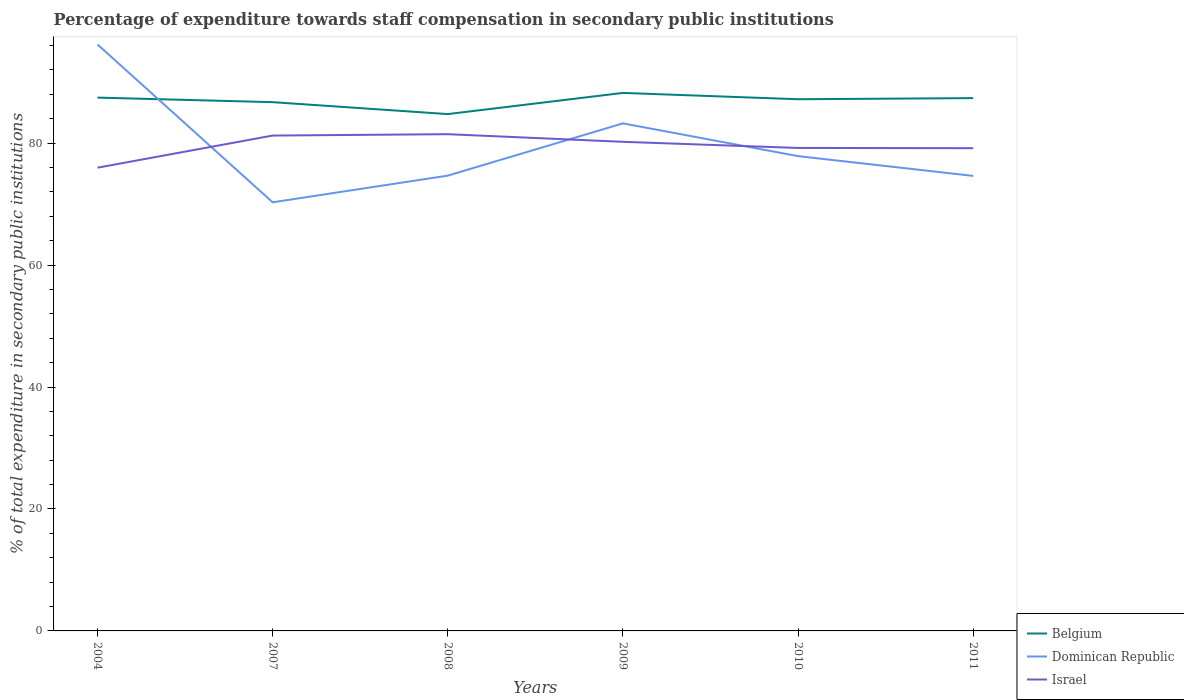How many different coloured lines are there?
Give a very brief answer. 3. Does the line corresponding to Belgium intersect with the line corresponding to Israel?
Give a very brief answer. No. Is the number of lines equal to the number of legend labels?
Provide a short and direct response. Yes. Across all years, what is the maximum percentage of expenditure towards staff compensation in Dominican Republic?
Your answer should be very brief. 70.3. In which year was the percentage of expenditure towards staff compensation in Dominican Republic maximum?
Provide a succinct answer. 2007. What is the total percentage of expenditure towards staff compensation in Dominican Republic in the graph?
Your answer should be very brief. 12.94. What is the difference between the highest and the second highest percentage of expenditure towards staff compensation in Belgium?
Make the answer very short. 3.47. How many lines are there?
Give a very brief answer. 3. What is the difference between two consecutive major ticks on the Y-axis?
Your answer should be compact. 20. Does the graph contain grids?
Give a very brief answer. No. How are the legend labels stacked?
Give a very brief answer. Vertical. What is the title of the graph?
Keep it short and to the point. Percentage of expenditure towards staff compensation in secondary public institutions. Does "New Zealand" appear as one of the legend labels in the graph?
Provide a short and direct response. No. What is the label or title of the X-axis?
Your answer should be very brief. Years. What is the label or title of the Y-axis?
Provide a succinct answer. % of total expenditure in secondary public institutions. What is the % of total expenditure in secondary public institutions in Belgium in 2004?
Your answer should be compact. 87.47. What is the % of total expenditure in secondary public institutions of Dominican Republic in 2004?
Your answer should be very brief. 96.18. What is the % of total expenditure in secondary public institutions in Israel in 2004?
Provide a short and direct response. 75.97. What is the % of total expenditure in secondary public institutions in Belgium in 2007?
Make the answer very short. 86.72. What is the % of total expenditure in secondary public institutions of Dominican Republic in 2007?
Keep it short and to the point. 70.3. What is the % of total expenditure in secondary public institutions of Israel in 2007?
Provide a succinct answer. 81.24. What is the % of total expenditure in secondary public institutions in Belgium in 2008?
Ensure brevity in your answer.  84.77. What is the % of total expenditure in secondary public institutions of Dominican Republic in 2008?
Make the answer very short. 74.67. What is the % of total expenditure in secondary public institutions in Israel in 2008?
Your answer should be compact. 81.47. What is the % of total expenditure in secondary public institutions of Belgium in 2009?
Provide a short and direct response. 88.24. What is the % of total expenditure in secondary public institutions in Dominican Republic in 2009?
Give a very brief answer. 83.24. What is the % of total expenditure in secondary public institutions in Israel in 2009?
Provide a succinct answer. 80.22. What is the % of total expenditure in secondary public institutions in Belgium in 2010?
Keep it short and to the point. 87.2. What is the % of total expenditure in secondary public institutions in Dominican Republic in 2010?
Provide a succinct answer. 77.87. What is the % of total expenditure in secondary public institutions of Israel in 2010?
Offer a very short reply. 79.21. What is the % of total expenditure in secondary public institutions in Belgium in 2011?
Offer a terse response. 87.38. What is the % of total expenditure in secondary public institutions in Dominican Republic in 2011?
Make the answer very short. 74.63. What is the % of total expenditure in secondary public institutions in Israel in 2011?
Your answer should be very brief. 79.17. Across all years, what is the maximum % of total expenditure in secondary public institutions in Belgium?
Offer a very short reply. 88.24. Across all years, what is the maximum % of total expenditure in secondary public institutions of Dominican Republic?
Keep it short and to the point. 96.18. Across all years, what is the maximum % of total expenditure in secondary public institutions of Israel?
Provide a succinct answer. 81.47. Across all years, what is the minimum % of total expenditure in secondary public institutions in Belgium?
Offer a very short reply. 84.77. Across all years, what is the minimum % of total expenditure in secondary public institutions of Dominican Republic?
Provide a succinct answer. 70.3. Across all years, what is the minimum % of total expenditure in secondary public institutions of Israel?
Your answer should be compact. 75.97. What is the total % of total expenditure in secondary public institutions of Belgium in the graph?
Provide a short and direct response. 521.78. What is the total % of total expenditure in secondary public institutions of Dominican Republic in the graph?
Keep it short and to the point. 476.89. What is the total % of total expenditure in secondary public institutions of Israel in the graph?
Keep it short and to the point. 477.29. What is the difference between the % of total expenditure in secondary public institutions in Belgium in 2004 and that in 2007?
Offer a terse response. 0.75. What is the difference between the % of total expenditure in secondary public institutions in Dominican Republic in 2004 and that in 2007?
Your answer should be very brief. 25.89. What is the difference between the % of total expenditure in secondary public institutions of Israel in 2004 and that in 2007?
Your answer should be compact. -5.27. What is the difference between the % of total expenditure in secondary public institutions of Belgium in 2004 and that in 2008?
Your answer should be very brief. 2.7. What is the difference between the % of total expenditure in secondary public institutions of Dominican Republic in 2004 and that in 2008?
Your answer should be compact. 21.51. What is the difference between the % of total expenditure in secondary public institutions in Israel in 2004 and that in 2008?
Keep it short and to the point. -5.49. What is the difference between the % of total expenditure in secondary public institutions of Belgium in 2004 and that in 2009?
Make the answer very short. -0.77. What is the difference between the % of total expenditure in secondary public institutions in Dominican Republic in 2004 and that in 2009?
Make the answer very short. 12.94. What is the difference between the % of total expenditure in secondary public institutions in Israel in 2004 and that in 2009?
Make the answer very short. -4.24. What is the difference between the % of total expenditure in secondary public institutions of Belgium in 2004 and that in 2010?
Provide a succinct answer. 0.27. What is the difference between the % of total expenditure in secondary public institutions of Dominican Republic in 2004 and that in 2010?
Provide a succinct answer. 18.31. What is the difference between the % of total expenditure in secondary public institutions in Israel in 2004 and that in 2010?
Your answer should be compact. -3.24. What is the difference between the % of total expenditure in secondary public institutions of Belgium in 2004 and that in 2011?
Ensure brevity in your answer.  0.08. What is the difference between the % of total expenditure in secondary public institutions in Dominican Republic in 2004 and that in 2011?
Offer a terse response. 21.56. What is the difference between the % of total expenditure in secondary public institutions in Israel in 2004 and that in 2011?
Make the answer very short. -3.2. What is the difference between the % of total expenditure in secondary public institutions in Belgium in 2007 and that in 2008?
Your answer should be compact. 1.96. What is the difference between the % of total expenditure in secondary public institutions in Dominican Republic in 2007 and that in 2008?
Give a very brief answer. -4.38. What is the difference between the % of total expenditure in secondary public institutions of Israel in 2007 and that in 2008?
Make the answer very short. -0.23. What is the difference between the % of total expenditure in secondary public institutions of Belgium in 2007 and that in 2009?
Ensure brevity in your answer.  -1.52. What is the difference between the % of total expenditure in secondary public institutions in Dominican Republic in 2007 and that in 2009?
Ensure brevity in your answer.  -12.95. What is the difference between the % of total expenditure in secondary public institutions in Israel in 2007 and that in 2009?
Your response must be concise. 1.03. What is the difference between the % of total expenditure in secondary public institutions in Belgium in 2007 and that in 2010?
Ensure brevity in your answer.  -0.48. What is the difference between the % of total expenditure in secondary public institutions in Dominican Republic in 2007 and that in 2010?
Make the answer very short. -7.58. What is the difference between the % of total expenditure in secondary public institutions in Israel in 2007 and that in 2010?
Your answer should be compact. 2.03. What is the difference between the % of total expenditure in secondary public institutions of Belgium in 2007 and that in 2011?
Your answer should be very brief. -0.66. What is the difference between the % of total expenditure in secondary public institutions in Dominican Republic in 2007 and that in 2011?
Your response must be concise. -4.33. What is the difference between the % of total expenditure in secondary public institutions in Israel in 2007 and that in 2011?
Your answer should be compact. 2.07. What is the difference between the % of total expenditure in secondary public institutions of Belgium in 2008 and that in 2009?
Ensure brevity in your answer.  -3.47. What is the difference between the % of total expenditure in secondary public institutions of Dominican Republic in 2008 and that in 2009?
Provide a succinct answer. -8.57. What is the difference between the % of total expenditure in secondary public institutions in Israel in 2008 and that in 2009?
Give a very brief answer. 1.25. What is the difference between the % of total expenditure in secondary public institutions in Belgium in 2008 and that in 2010?
Make the answer very short. -2.43. What is the difference between the % of total expenditure in secondary public institutions in Dominican Republic in 2008 and that in 2010?
Provide a short and direct response. -3.2. What is the difference between the % of total expenditure in secondary public institutions of Israel in 2008 and that in 2010?
Give a very brief answer. 2.26. What is the difference between the % of total expenditure in secondary public institutions in Belgium in 2008 and that in 2011?
Your response must be concise. -2.62. What is the difference between the % of total expenditure in secondary public institutions of Dominican Republic in 2008 and that in 2011?
Your answer should be very brief. 0.05. What is the difference between the % of total expenditure in secondary public institutions of Israel in 2008 and that in 2011?
Your answer should be very brief. 2.3. What is the difference between the % of total expenditure in secondary public institutions of Belgium in 2009 and that in 2010?
Provide a succinct answer. 1.04. What is the difference between the % of total expenditure in secondary public institutions in Dominican Republic in 2009 and that in 2010?
Your answer should be very brief. 5.37. What is the difference between the % of total expenditure in secondary public institutions of Israel in 2009 and that in 2010?
Ensure brevity in your answer.  1. What is the difference between the % of total expenditure in secondary public institutions in Belgium in 2009 and that in 2011?
Your answer should be compact. 0.85. What is the difference between the % of total expenditure in secondary public institutions of Dominican Republic in 2009 and that in 2011?
Offer a very short reply. 8.61. What is the difference between the % of total expenditure in secondary public institutions in Israel in 2009 and that in 2011?
Your answer should be very brief. 1.04. What is the difference between the % of total expenditure in secondary public institutions of Belgium in 2010 and that in 2011?
Your answer should be compact. -0.18. What is the difference between the % of total expenditure in secondary public institutions in Dominican Republic in 2010 and that in 2011?
Offer a terse response. 3.24. What is the difference between the % of total expenditure in secondary public institutions in Israel in 2010 and that in 2011?
Offer a very short reply. 0.04. What is the difference between the % of total expenditure in secondary public institutions of Belgium in 2004 and the % of total expenditure in secondary public institutions of Dominican Republic in 2007?
Give a very brief answer. 17.17. What is the difference between the % of total expenditure in secondary public institutions of Belgium in 2004 and the % of total expenditure in secondary public institutions of Israel in 2007?
Your response must be concise. 6.22. What is the difference between the % of total expenditure in secondary public institutions in Dominican Republic in 2004 and the % of total expenditure in secondary public institutions in Israel in 2007?
Offer a very short reply. 14.94. What is the difference between the % of total expenditure in secondary public institutions of Belgium in 2004 and the % of total expenditure in secondary public institutions of Dominican Republic in 2008?
Make the answer very short. 12.79. What is the difference between the % of total expenditure in secondary public institutions of Belgium in 2004 and the % of total expenditure in secondary public institutions of Israel in 2008?
Give a very brief answer. 6. What is the difference between the % of total expenditure in secondary public institutions of Dominican Republic in 2004 and the % of total expenditure in secondary public institutions of Israel in 2008?
Keep it short and to the point. 14.72. What is the difference between the % of total expenditure in secondary public institutions of Belgium in 2004 and the % of total expenditure in secondary public institutions of Dominican Republic in 2009?
Offer a terse response. 4.23. What is the difference between the % of total expenditure in secondary public institutions of Belgium in 2004 and the % of total expenditure in secondary public institutions of Israel in 2009?
Keep it short and to the point. 7.25. What is the difference between the % of total expenditure in secondary public institutions in Dominican Republic in 2004 and the % of total expenditure in secondary public institutions in Israel in 2009?
Your answer should be compact. 15.97. What is the difference between the % of total expenditure in secondary public institutions of Belgium in 2004 and the % of total expenditure in secondary public institutions of Dominican Republic in 2010?
Your response must be concise. 9.6. What is the difference between the % of total expenditure in secondary public institutions in Belgium in 2004 and the % of total expenditure in secondary public institutions in Israel in 2010?
Offer a terse response. 8.26. What is the difference between the % of total expenditure in secondary public institutions in Dominican Republic in 2004 and the % of total expenditure in secondary public institutions in Israel in 2010?
Offer a very short reply. 16.97. What is the difference between the % of total expenditure in secondary public institutions in Belgium in 2004 and the % of total expenditure in secondary public institutions in Dominican Republic in 2011?
Make the answer very short. 12.84. What is the difference between the % of total expenditure in secondary public institutions of Belgium in 2004 and the % of total expenditure in secondary public institutions of Israel in 2011?
Your response must be concise. 8.29. What is the difference between the % of total expenditure in secondary public institutions in Dominican Republic in 2004 and the % of total expenditure in secondary public institutions in Israel in 2011?
Provide a succinct answer. 17.01. What is the difference between the % of total expenditure in secondary public institutions in Belgium in 2007 and the % of total expenditure in secondary public institutions in Dominican Republic in 2008?
Your answer should be very brief. 12.05. What is the difference between the % of total expenditure in secondary public institutions in Belgium in 2007 and the % of total expenditure in secondary public institutions in Israel in 2008?
Your answer should be compact. 5.25. What is the difference between the % of total expenditure in secondary public institutions of Dominican Republic in 2007 and the % of total expenditure in secondary public institutions of Israel in 2008?
Your answer should be very brief. -11.17. What is the difference between the % of total expenditure in secondary public institutions of Belgium in 2007 and the % of total expenditure in secondary public institutions of Dominican Republic in 2009?
Provide a short and direct response. 3.48. What is the difference between the % of total expenditure in secondary public institutions of Belgium in 2007 and the % of total expenditure in secondary public institutions of Israel in 2009?
Your answer should be very brief. 6.5. What is the difference between the % of total expenditure in secondary public institutions of Dominican Republic in 2007 and the % of total expenditure in secondary public institutions of Israel in 2009?
Your response must be concise. -9.92. What is the difference between the % of total expenditure in secondary public institutions in Belgium in 2007 and the % of total expenditure in secondary public institutions in Dominican Republic in 2010?
Ensure brevity in your answer.  8.85. What is the difference between the % of total expenditure in secondary public institutions of Belgium in 2007 and the % of total expenditure in secondary public institutions of Israel in 2010?
Offer a terse response. 7.51. What is the difference between the % of total expenditure in secondary public institutions of Dominican Republic in 2007 and the % of total expenditure in secondary public institutions of Israel in 2010?
Make the answer very short. -8.92. What is the difference between the % of total expenditure in secondary public institutions of Belgium in 2007 and the % of total expenditure in secondary public institutions of Dominican Republic in 2011?
Keep it short and to the point. 12.09. What is the difference between the % of total expenditure in secondary public institutions of Belgium in 2007 and the % of total expenditure in secondary public institutions of Israel in 2011?
Your response must be concise. 7.55. What is the difference between the % of total expenditure in secondary public institutions in Dominican Republic in 2007 and the % of total expenditure in secondary public institutions in Israel in 2011?
Make the answer very short. -8.88. What is the difference between the % of total expenditure in secondary public institutions in Belgium in 2008 and the % of total expenditure in secondary public institutions in Dominican Republic in 2009?
Give a very brief answer. 1.52. What is the difference between the % of total expenditure in secondary public institutions in Belgium in 2008 and the % of total expenditure in secondary public institutions in Israel in 2009?
Offer a very short reply. 4.55. What is the difference between the % of total expenditure in secondary public institutions in Dominican Republic in 2008 and the % of total expenditure in secondary public institutions in Israel in 2009?
Your answer should be compact. -5.54. What is the difference between the % of total expenditure in secondary public institutions of Belgium in 2008 and the % of total expenditure in secondary public institutions of Dominican Republic in 2010?
Provide a succinct answer. 6.89. What is the difference between the % of total expenditure in secondary public institutions of Belgium in 2008 and the % of total expenditure in secondary public institutions of Israel in 2010?
Give a very brief answer. 5.55. What is the difference between the % of total expenditure in secondary public institutions in Dominican Republic in 2008 and the % of total expenditure in secondary public institutions in Israel in 2010?
Make the answer very short. -4.54. What is the difference between the % of total expenditure in secondary public institutions of Belgium in 2008 and the % of total expenditure in secondary public institutions of Dominican Republic in 2011?
Your answer should be compact. 10.14. What is the difference between the % of total expenditure in secondary public institutions in Belgium in 2008 and the % of total expenditure in secondary public institutions in Israel in 2011?
Offer a very short reply. 5.59. What is the difference between the % of total expenditure in secondary public institutions in Dominican Republic in 2008 and the % of total expenditure in secondary public institutions in Israel in 2011?
Offer a very short reply. -4.5. What is the difference between the % of total expenditure in secondary public institutions of Belgium in 2009 and the % of total expenditure in secondary public institutions of Dominican Republic in 2010?
Keep it short and to the point. 10.37. What is the difference between the % of total expenditure in secondary public institutions of Belgium in 2009 and the % of total expenditure in secondary public institutions of Israel in 2010?
Offer a terse response. 9.03. What is the difference between the % of total expenditure in secondary public institutions of Dominican Republic in 2009 and the % of total expenditure in secondary public institutions of Israel in 2010?
Provide a short and direct response. 4.03. What is the difference between the % of total expenditure in secondary public institutions in Belgium in 2009 and the % of total expenditure in secondary public institutions in Dominican Republic in 2011?
Make the answer very short. 13.61. What is the difference between the % of total expenditure in secondary public institutions of Belgium in 2009 and the % of total expenditure in secondary public institutions of Israel in 2011?
Your answer should be very brief. 9.07. What is the difference between the % of total expenditure in secondary public institutions of Dominican Republic in 2009 and the % of total expenditure in secondary public institutions of Israel in 2011?
Provide a succinct answer. 4.07. What is the difference between the % of total expenditure in secondary public institutions of Belgium in 2010 and the % of total expenditure in secondary public institutions of Dominican Republic in 2011?
Ensure brevity in your answer.  12.57. What is the difference between the % of total expenditure in secondary public institutions in Belgium in 2010 and the % of total expenditure in secondary public institutions in Israel in 2011?
Provide a succinct answer. 8.03. What is the difference between the % of total expenditure in secondary public institutions in Dominican Republic in 2010 and the % of total expenditure in secondary public institutions in Israel in 2011?
Your answer should be compact. -1.3. What is the average % of total expenditure in secondary public institutions of Belgium per year?
Your answer should be very brief. 86.96. What is the average % of total expenditure in secondary public institutions in Dominican Republic per year?
Your answer should be very brief. 79.48. What is the average % of total expenditure in secondary public institutions of Israel per year?
Your answer should be compact. 79.55. In the year 2004, what is the difference between the % of total expenditure in secondary public institutions of Belgium and % of total expenditure in secondary public institutions of Dominican Republic?
Provide a short and direct response. -8.72. In the year 2004, what is the difference between the % of total expenditure in secondary public institutions in Belgium and % of total expenditure in secondary public institutions in Israel?
Your answer should be compact. 11.49. In the year 2004, what is the difference between the % of total expenditure in secondary public institutions in Dominican Republic and % of total expenditure in secondary public institutions in Israel?
Your response must be concise. 20.21. In the year 2007, what is the difference between the % of total expenditure in secondary public institutions in Belgium and % of total expenditure in secondary public institutions in Dominican Republic?
Offer a terse response. 16.43. In the year 2007, what is the difference between the % of total expenditure in secondary public institutions of Belgium and % of total expenditure in secondary public institutions of Israel?
Ensure brevity in your answer.  5.48. In the year 2007, what is the difference between the % of total expenditure in secondary public institutions of Dominican Republic and % of total expenditure in secondary public institutions of Israel?
Ensure brevity in your answer.  -10.95. In the year 2008, what is the difference between the % of total expenditure in secondary public institutions in Belgium and % of total expenditure in secondary public institutions in Dominican Republic?
Offer a terse response. 10.09. In the year 2008, what is the difference between the % of total expenditure in secondary public institutions in Belgium and % of total expenditure in secondary public institutions in Israel?
Offer a terse response. 3.3. In the year 2008, what is the difference between the % of total expenditure in secondary public institutions in Dominican Republic and % of total expenditure in secondary public institutions in Israel?
Make the answer very short. -6.8. In the year 2009, what is the difference between the % of total expenditure in secondary public institutions of Belgium and % of total expenditure in secondary public institutions of Dominican Republic?
Provide a short and direct response. 5. In the year 2009, what is the difference between the % of total expenditure in secondary public institutions in Belgium and % of total expenditure in secondary public institutions in Israel?
Your response must be concise. 8.02. In the year 2009, what is the difference between the % of total expenditure in secondary public institutions in Dominican Republic and % of total expenditure in secondary public institutions in Israel?
Give a very brief answer. 3.02. In the year 2010, what is the difference between the % of total expenditure in secondary public institutions in Belgium and % of total expenditure in secondary public institutions in Dominican Republic?
Ensure brevity in your answer.  9.33. In the year 2010, what is the difference between the % of total expenditure in secondary public institutions of Belgium and % of total expenditure in secondary public institutions of Israel?
Your answer should be compact. 7.99. In the year 2010, what is the difference between the % of total expenditure in secondary public institutions of Dominican Republic and % of total expenditure in secondary public institutions of Israel?
Offer a terse response. -1.34. In the year 2011, what is the difference between the % of total expenditure in secondary public institutions of Belgium and % of total expenditure in secondary public institutions of Dominican Republic?
Give a very brief answer. 12.76. In the year 2011, what is the difference between the % of total expenditure in secondary public institutions of Belgium and % of total expenditure in secondary public institutions of Israel?
Your response must be concise. 8.21. In the year 2011, what is the difference between the % of total expenditure in secondary public institutions of Dominican Republic and % of total expenditure in secondary public institutions of Israel?
Your answer should be very brief. -4.55. What is the ratio of the % of total expenditure in secondary public institutions in Belgium in 2004 to that in 2007?
Offer a very short reply. 1.01. What is the ratio of the % of total expenditure in secondary public institutions in Dominican Republic in 2004 to that in 2007?
Provide a short and direct response. 1.37. What is the ratio of the % of total expenditure in secondary public institutions in Israel in 2004 to that in 2007?
Make the answer very short. 0.94. What is the ratio of the % of total expenditure in secondary public institutions in Belgium in 2004 to that in 2008?
Ensure brevity in your answer.  1.03. What is the ratio of the % of total expenditure in secondary public institutions in Dominican Republic in 2004 to that in 2008?
Your answer should be very brief. 1.29. What is the ratio of the % of total expenditure in secondary public institutions of Israel in 2004 to that in 2008?
Keep it short and to the point. 0.93. What is the ratio of the % of total expenditure in secondary public institutions of Dominican Republic in 2004 to that in 2009?
Give a very brief answer. 1.16. What is the ratio of the % of total expenditure in secondary public institutions of Israel in 2004 to that in 2009?
Give a very brief answer. 0.95. What is the ratio of the % of total expenditure in secondary public institutions of Dominican Republic in 2004 to that in 2010?
Provide a short and direct response. 1.24. What is the ratio of the % of total expenditure in secondary public institutions of Israel in 2004 to that in 2010?
Your answer should be compact. 0.96. What is the ratio of the % of total expenditure in secondary public institutions in Dominican Republic in 2004 to that in 2011?
Your answer should be compact. 1.29. What is the ratio of the % of total expenditure in secondary public institutions of Israel in 2004 to that in 2011?
Give a very brief answer. 0.96. What is the ratio of the % of total expenditure in secondary public institutions in Belgium in 2007 to that in 2008?
Offer a very short reply. 1.02. What is the ratio of the % of total expenditure in secondary public institutions of Dominican Republic in 2007 to that in 2008?
Keep it short and to the point. 0.94. What is the ratio of the % of total expenditure in secondary public institutions of Israel in 2007 to that in 2008?
Make the answer very short. 1. What is the ratio of the % of total expenditure in secondary public institutions of Belgium in 2007 to that in 2009?
Your answer should be compact. 0.98. What is the ratio of the % of total expenditure in secondary public institutions of Dominican Republic in 2007 to that in 2009?
Provide a succinct answer. 0.84. What is the ratio of the % of total expenditure in secondary public institutions of Israel in 2007 to that in 2009?
Offer a very short reply. 1.01. What is the ratio of the % of total expenditure in secondary public institutions of Dominican Republic in 2007 to that in 2010?
Your response must be concise. 0.9. What is the ratio of the % of total expenditure in secondary public institutions of Israel in 2007 to that in 2010?
Your answer should be compact. 1.03. What is the ratio of the % of total expenditure in secondary public institutions in Belgium in 2007 to that in 2011?
Your response must be concise. 0.99. What is the ratio of the % of total expenditure in secondary public institutions of Dominican Republic in 2007 to that in 2011?
Provide a short and direct response. 0.94. What is the ratio of the % of total expenditure in secondary public institutions of Israel in 2007 to that in 2011?
Give a very brief answer. 1.03. What is the ratio of the % of total expenditure in secondary public institutions in Belgium in 2008 to that in 2009?
Provide a succinct answer. 0.96. What is the ratio of the % of total expenditure in secondary public institutions of Dominican Republic in 2008 to that in 2009?
Offer a terse response. 0.9. What is the ratio of the % of total expenditure in secondary public institutions in Israel in 2008 to that in 2009?
Make the answer very short. 1.02. What is the ratio of the % of total expenditure in secondary public institutions in Belgium in 2008 to that in 2010?
Make the answer very short. 0.97. What is the ratio of the % of total expenditure in secondary public institutions of Dominican Republic in 2008 to that in 2010?
Offer a very short reply. 0.96. What is the ratio of the % of total expenditure in secondary public institutions of Israel in 2008 to that in 2010?
Keep it short and to the point. 1.03. What is the ratio of the % of total expenditure in secondary public institutions of Belgium in 2008 to that in 2011?
Your answer should be compact. 0.97. What is the ratio of the % of total expenditure in secondary public institutions in Dominican Republic in 2008 to that in 2011?
Keep it short and to the point. 1. What is the ratio of the % of total expenditure in secondary public institutions of Belgium in 2009 to that in 2010?
Offer a terse response. 1.01. What is the ratio of the % of total expenditure in secondary public institutions of Dominican Republic in 2009 to that in 2010?
Make the answer very short. 1.07. What is the ratio of the % of total expenditure in secondary public institutions in Israel in 2009 to that in 2010?
Give a very brief answer. 1.01. What is the ratio of the % of total expenditure in secondary public institutions of Belgium in 2009 to that in 2011?
Ensure brevity in your answer.  1.01. What is the ratio of the % of total expenditure in secondary public institutions in Dominican Republic in 2009 to that in 2011?
Your answer should be very brief. 1.12. What is the ratio of the % of total expenditure in secondary public institutions in Israel in 2009 to that in 2011?
Your response must be concise. 1.01. What is the ratio of the % of total expenditure in secondary public institutions in Dominican Republic in 2010 to that in 2011?
Your response must be concise. 1.04. What is the difference between the highest and the second highest % of total expenditure in secondary public institutions of Belgium?
Your response must be concise. 0.77. What is the difference between the highest and the second highest % of total expenditure in secondary public institutions in Dominican Republic?
Provide a short and direct response. 12.94. What is the difference between the highest and the second highest % of total expenditure in secondary public institutions in Israel?
Keep it short and to the point. 0.23. What is the difference between the highest and the lowest % of total expenditure in secondary public institutions in Belgium?
Give a very brief answer. 3.47. What is the difference between the highest and the lowest % of total expenditure in secondary public institutions of Dominican Republic?
Offer a terse response. 25.89. What is the difference between the highest and the lowest % of total expenditure in secondary public institutions in Israel?
Give a very brief answer. 5.49. 